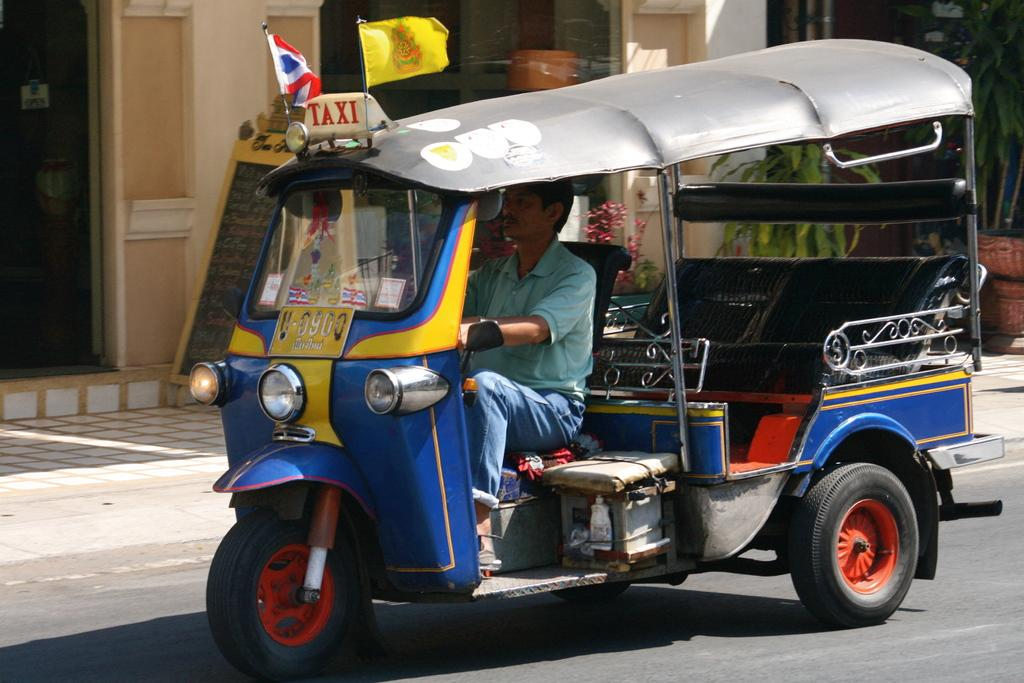What is the main subject of the picture? The main subject of the picture is an auto. Who or what is associated with the auto in the image? A person is riding the auto. What can be seen in the background of the picture? There is a building in the background of the picture. What features does the building have? The building has doors and windows. What type of attraction can be seen in the picture? There is no attraction present in the image; it features an auto with a person riding it and a building in the background. What is the person doing during recess in the picture? The image does not depict a recess or any activity related to it; it shows a person riding an auto and a building in the background. 